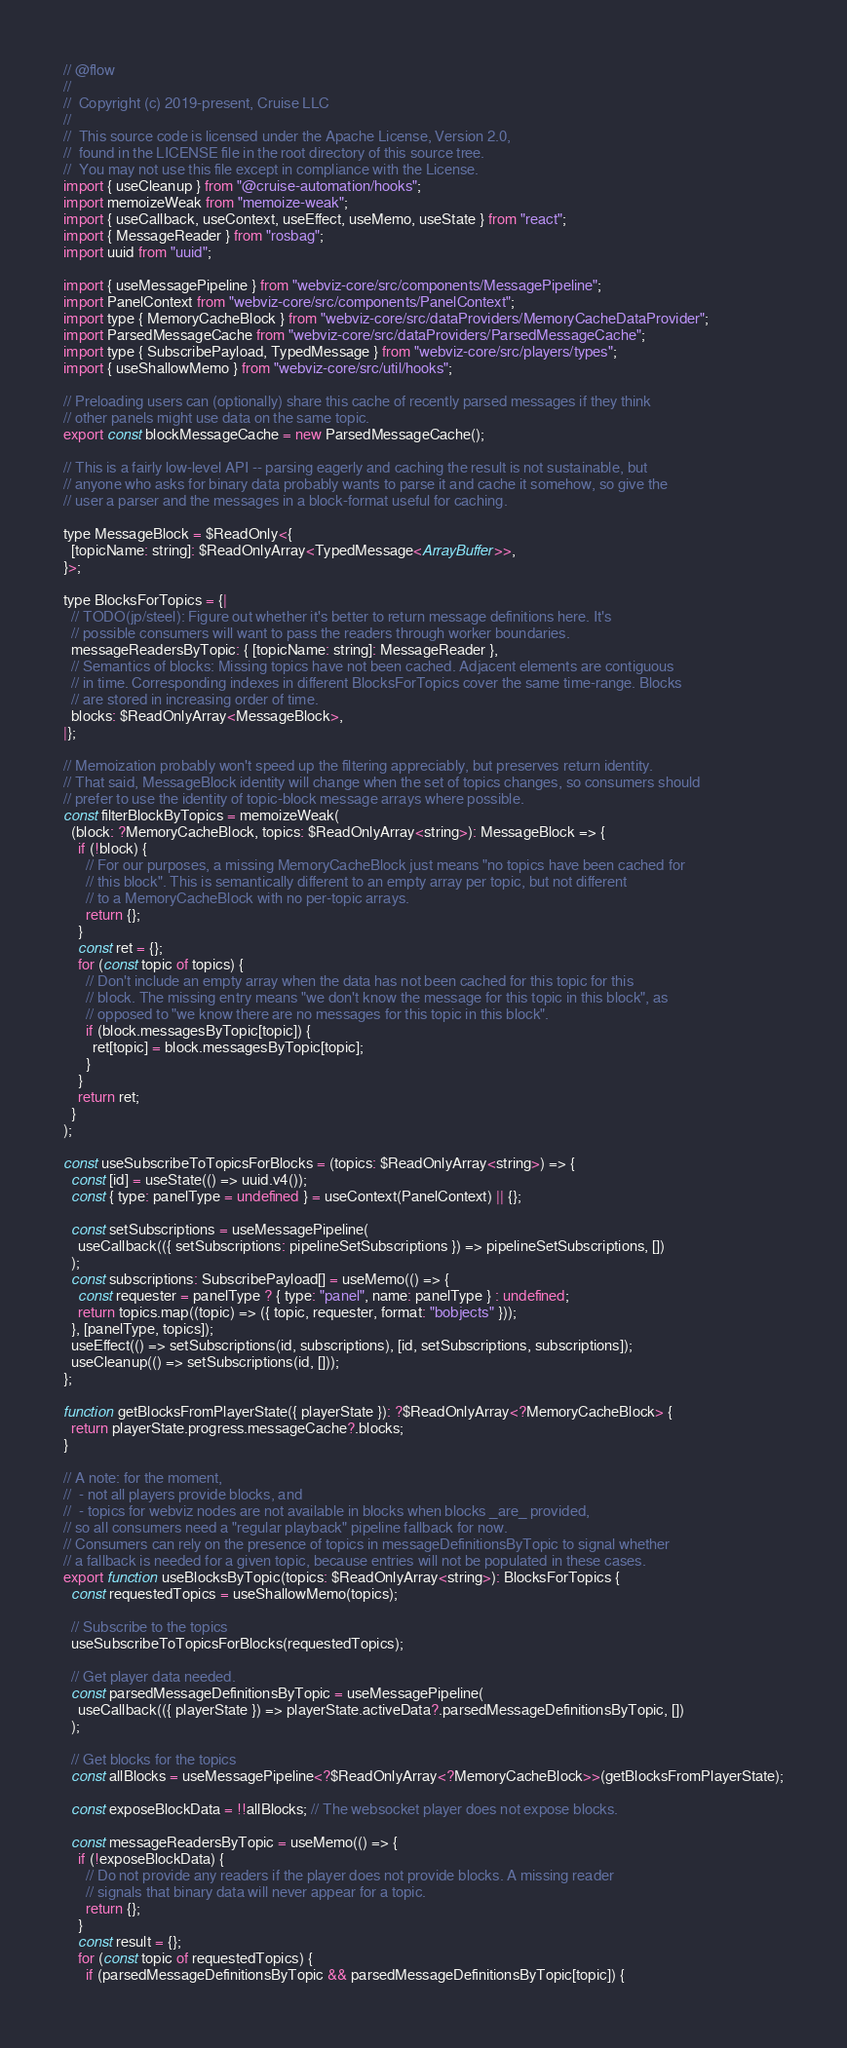<code> <loc_0><loc_0><loc_500><loc_500><_JavaScript_>// @flow
//
//  Copyright (c) 2019-present, Cruise LLC
//
//  This source code is licensed under the Apache License, Version 2.0,
//  found in the LICENSE file in the root directory of this source tree.
//  You may not use this file except in compliance with the License.
import { useCleanup } from "@cruise-automation/hooks";
import memoizeWeak from "memoize-weak";
import { useCallback, useContext, useEffect, useMemo, useState } from "react";
import { MessageReader } from "rosbag";
import uuid from "uuid";

import { useMessagePipeline } from "webviz-core/src/components/MessagePipeline";
import PanelContext from "webviz-core/src/components/PanelContext";
import type { MemoryCacheBlock } from "webviz-core/src/dataProviders/MemoryCacheDataProvider";
import ParsedMessageCache from "webviz-core/src/dataProviders/ParsedMessageCache";
import type { SubscribePayload, TypedMessage } from "webviz-core/src/players/types";
import { useShallowMemo } from "webviz-core/src/util/hooks";

// Preloading users can (optionally) share this cache of recently parsed messages if they think
// other panels might use data on the same topic.
export const blockMessageCache = new ParsedMessageCache();

// This is a fairly low-level API -- parsing eagerly and caching the result is not sustainable, but
// anyone who asks for binary data probably wants to parse it and cache it somehow, so give the
// user a parser and the messages in a block-format useful for caching.

type MessageBlock = $ReadOnly<{
  [topicName: string]: $ReadOnlyArray<TypedMessage<ArrayBuffer>>,
}>;

type BlocksForTopics = {|
  // TODO(jp/steel): Figure out whether it's better to return message definitions here. It's
  // possible consumers will want to pass the readers through worker boundaries.
  messageReadersByTopic: { [topicName: string]: MessageReader },
  // Semantics of blocks: Missing topics have not been cached. Adjacent elements are contiguous
  // in time. Corresponding indexes in different BlocksForTopics cover the same time-range. Blocks
  // are stored in increasing order of time.
  blocks: $ReadOnlyArray<MessageBlock>,
|};

// Memoization probably won't speed up the filtering appreciably, but preserves return identity.
// That said, MessageBlock identity will change when the set of topics changes, so consumers should
// prefer to use the identity of topic-block message arrays where possible.
const filterBlockByTopics = memoizeWeak(
  (block: ?MemoryCacheBlock, topics: $ReadOnlyArray<string>): MessageBlock => {
    if (!block) {
      // For our purposes, a missing MemoryCacheBlock just means "no topics have been cached for
      // this block". This is semantically different to an empty array per topic, but not different
      // to a MemoryCacheBlock with no per-topic arrays.
      return {};
    }
    const ret = {};
    for (const topic of topics) {
      // Don't include an empty array when the data has not been cached for this topic for this
      // block. The missing entry means "we don't know the message for this topic in this block", as
      // opposed to "we know there are no messages for this topic in this block".
      if (block.messagesByTopic[topic]) {
        ret[topic] = block.messagesByTopic[topic];
      }
    }
    return ret;
  }
);

const useSubscribeToTopicsForBlocks = (topics: $ReadOnlyArray<string>) => {
  const [id] = useState(() => uuid.v4());
  const { type: panelType = undefined } = useContext(PanelContext) || {};

  const setSubscriptions = useMessagePipeline(
    useCallback(({ setSubscriptions: pipelineSetSubscriptions }) => pipelineSetSubscriptions, [])
  );
  const subscriptions: SubscribePayload[] = useMemo(() => {
    const requester = panelType ? { type: "panel", name: panelType } : undefined;
    return topics.map((topic) => ({ topic, requester, format: "bobjects" }));
  }, [panelType, topics]);
  useEffect(() => setSubscriptions(id, subscriptions), [id, setSubscriptions, subscriptions]);
  useCleanup(() => setSubscriptions(id, []));
};

function getBlocksFromPlayerState({ playerState }): ?$ReadOnlyArray<?MemoryCacheBlock> {
  return playerState.progress.messageCache?.blocks;
}

// A note: for the moment,
//  - not all players provide blocks, and
//  - topics for webviz nodes are not available in blocks when blocks _are_ provided,
// so all consumers need a "regular playback" pipeline fallback for now.
// Consumers can rely on the presence of topics in messageDefinitionsByTopic to signal whether
// a fallback is needed for a given topic, because entries will not be populated in these cases.
export function useBlocksByTopic(topics: $ReadOnlyArray<string>): BlocksForTopics {
  const requestedTopics = useShallowMemo(topics);

  // Subscribe to the topics
  useSubscribeToTopicsForBlocks(requestedTopics);

  // Get player data needed.
  const parsedMessageDefinitionsByTopic = useMessagePipeline(
    useCallback(({ playerState }) => playerState.activeData?.parsedMessageDefinitionsByTopic, [])
  );

  // Get blocks for the topics
  const allBlocks = useMessagePipeline<?$ReadOnlyArray<?MemoryCacheBlock>>(getBlocksFromPlayerState);

  const exposeBlockData = !!allBlocks; // The websocket player does not expose blocks.

  const messageReadersByTopic = useMemo(() => {
    if (!exposeBlockData) {
      // Do not provide any readers if the player does not provide blocks. A missing reader
      // signals that binary data will never appear for a topic.
      return {};
    }
    const result = {};
    for (const topic of requestedTopics) {
      if (parsedMessageDefinitionsByTopic && parsedMessageDefinitionsByTopic[topic]) {</code> 